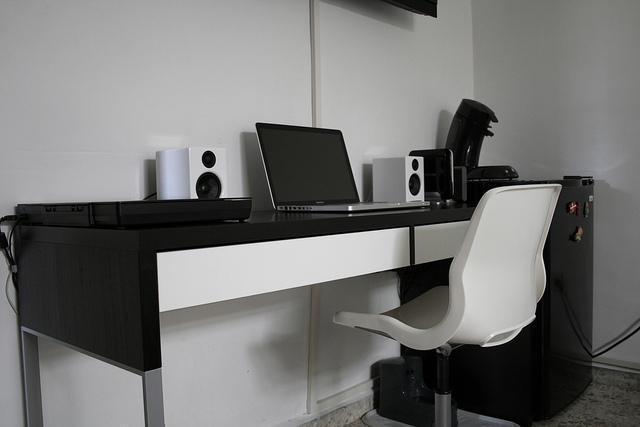Which object in the room can create the most noise?
Choose the right answer from the provided options to respond to the question.
Options: Laptop, chair, desk, speakers. Speakers. 